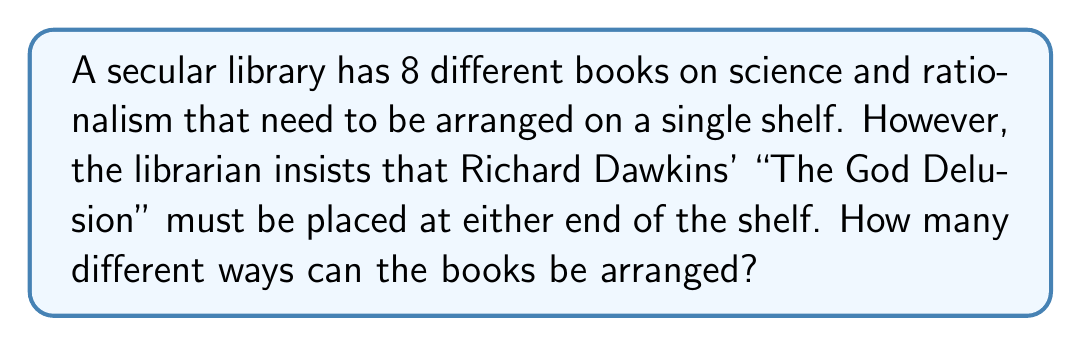Show me your answer to this math problem. Let's approach this step-by-step:

1) First, we need to consider that "The God Delusion" can be placed in 2 positions: either at the left end or the right end of the shelf.

2) Once we've placed "The God Delusion", we need to arrange the remaining 7 books.

3) This is a permutation problem. The number of ways to arrange n distinct objects is given by n!

4) In this case, we have 7 books to arrange in 7 positions, so we calculate 7!

5) However, we need to multiply this by 2 because "The God Delusion" can be in 2 positions.

6) Therefore, the total number of arrangements is:

   $$2 \times 7!$$

7) Let's calculate this:
   
   $$2 \times 7! = 2 \times (7 \times 6 \times 5 \times 4 \times 3 \times 2 \times 1) = 2 \times 5040 = 10080$$

Thus, there are 10,080 different ways to arrange the books.
Answer: 10,080 